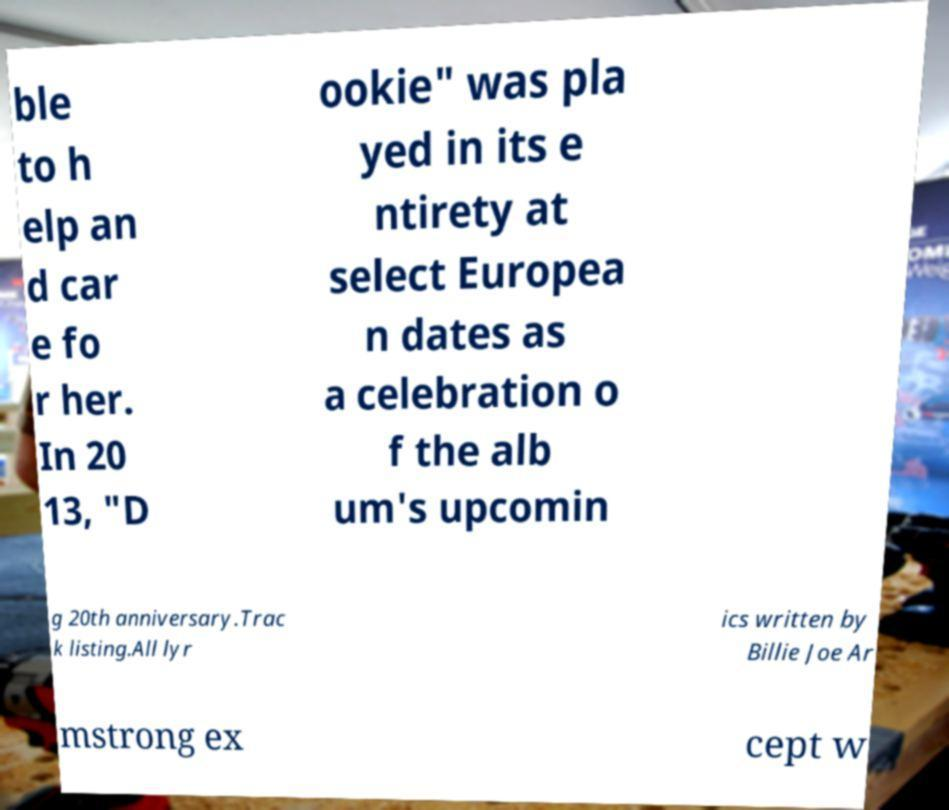Please read and relay the text visible in this image. What does it say? ble to h elp an d car e fo r her. In 20 13, "D ookie" was pla yed in its e ntirety at select Europea n dates as a celebration o f the alb um's upcomin g 20th anniversary.Trac k listing.All lyr ics written by Billie Joe Ar mstrong ex cept w 